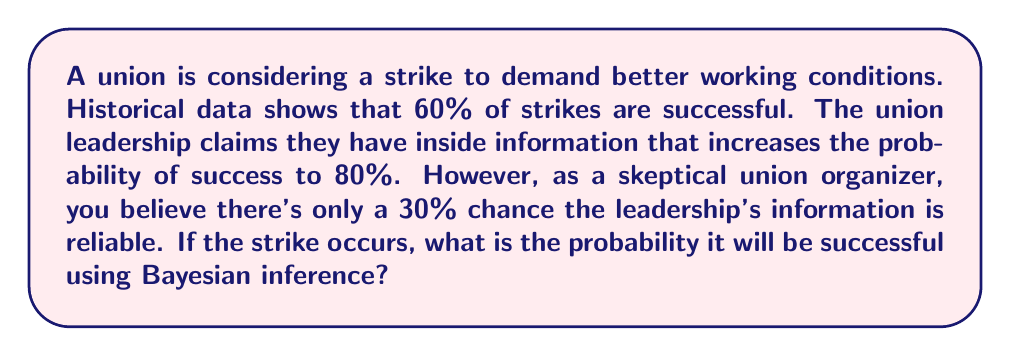Provide a solution to this math problem. Let's approach this using Bayesian inference:

1) Define our events:
   S: Strike is successful
   I: Leadership's information is reliable

2) Given probabilities:
   P(S) = 0.60 (prior probability of success)
   P(S|I) = 0.80 (probability of success given reliable information)
   P(I) = 0.30 (probability leadership's information is reliable)

3) We need to find P(S|strike occurs), which we can calculate using the law of total probability:

   P(S|strike occurs) = P(S|I) * P(I) + P(S|not I) * P(not I)

4) We know P(S|I) and P(I), but we need to calculate P(S|not I) and P(not I):
   
   P(not I) = 1 - P(I) = 1 - 0.30 = 0.70
   
   P(S|not I) = P(S) = 0.60 (if the information is not reliable, we default to the prior probability)

5) Now we can plug these values into our equation:

   P(S|strike occurs) = 0.80 * 0.30 + 0.60 * 0.70

6) Calculating:
   
   P(S|strike occurs) = 0.24 + 0.42 = 0.66

Therefore, using Bayesian inference, the probability that the strike will be successful is 0.66 or 66%.
Answer: 0.66 